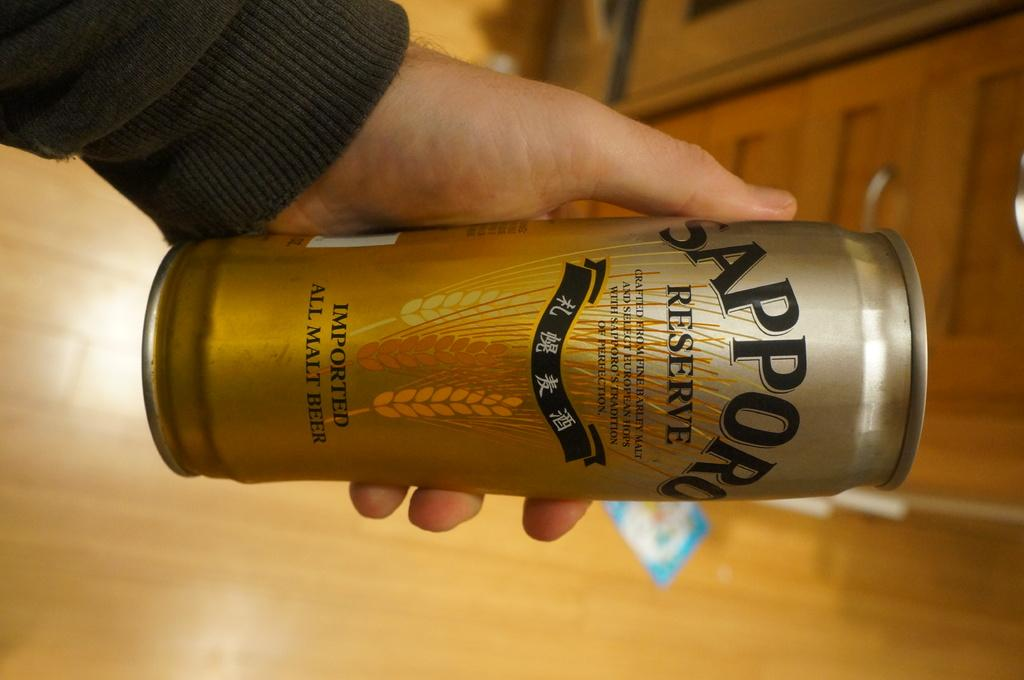<image>
Share a concise interpretation of the image provided. Someone holds a can of Sapporo Reserve sideways. 